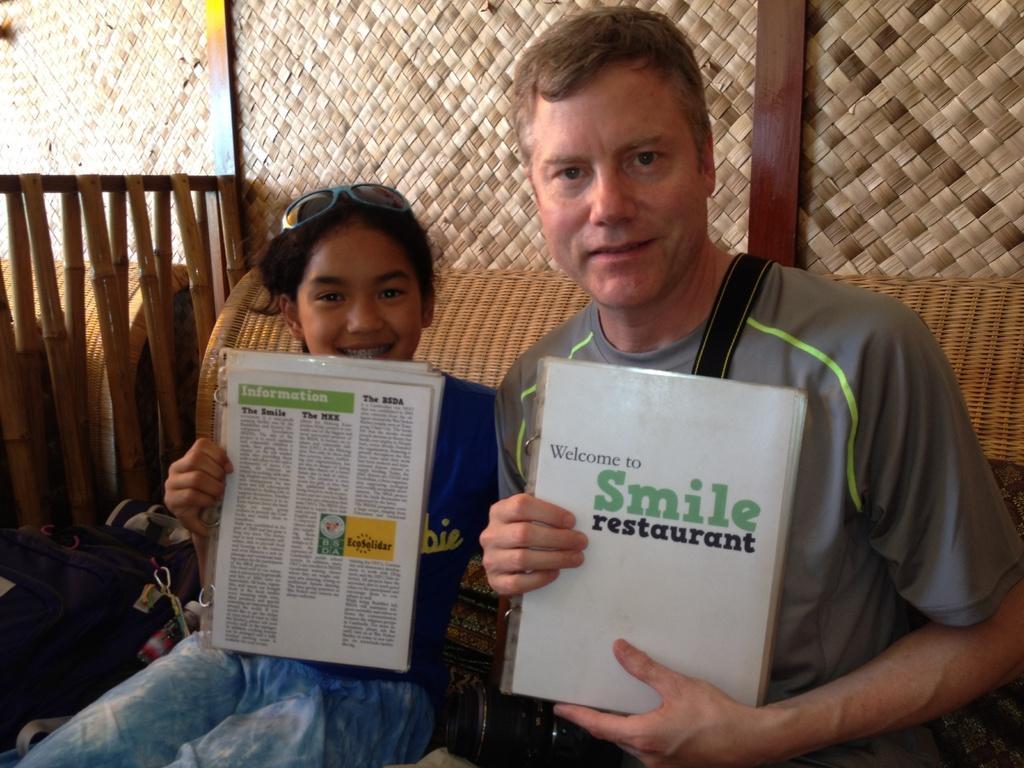Can you describe this image briefly? Here I can see a man and a girl are sitting, holding books in their hands, smiling and giving pose for the picture. At the back of these people there is a wall. On the left side there are few sticks. 